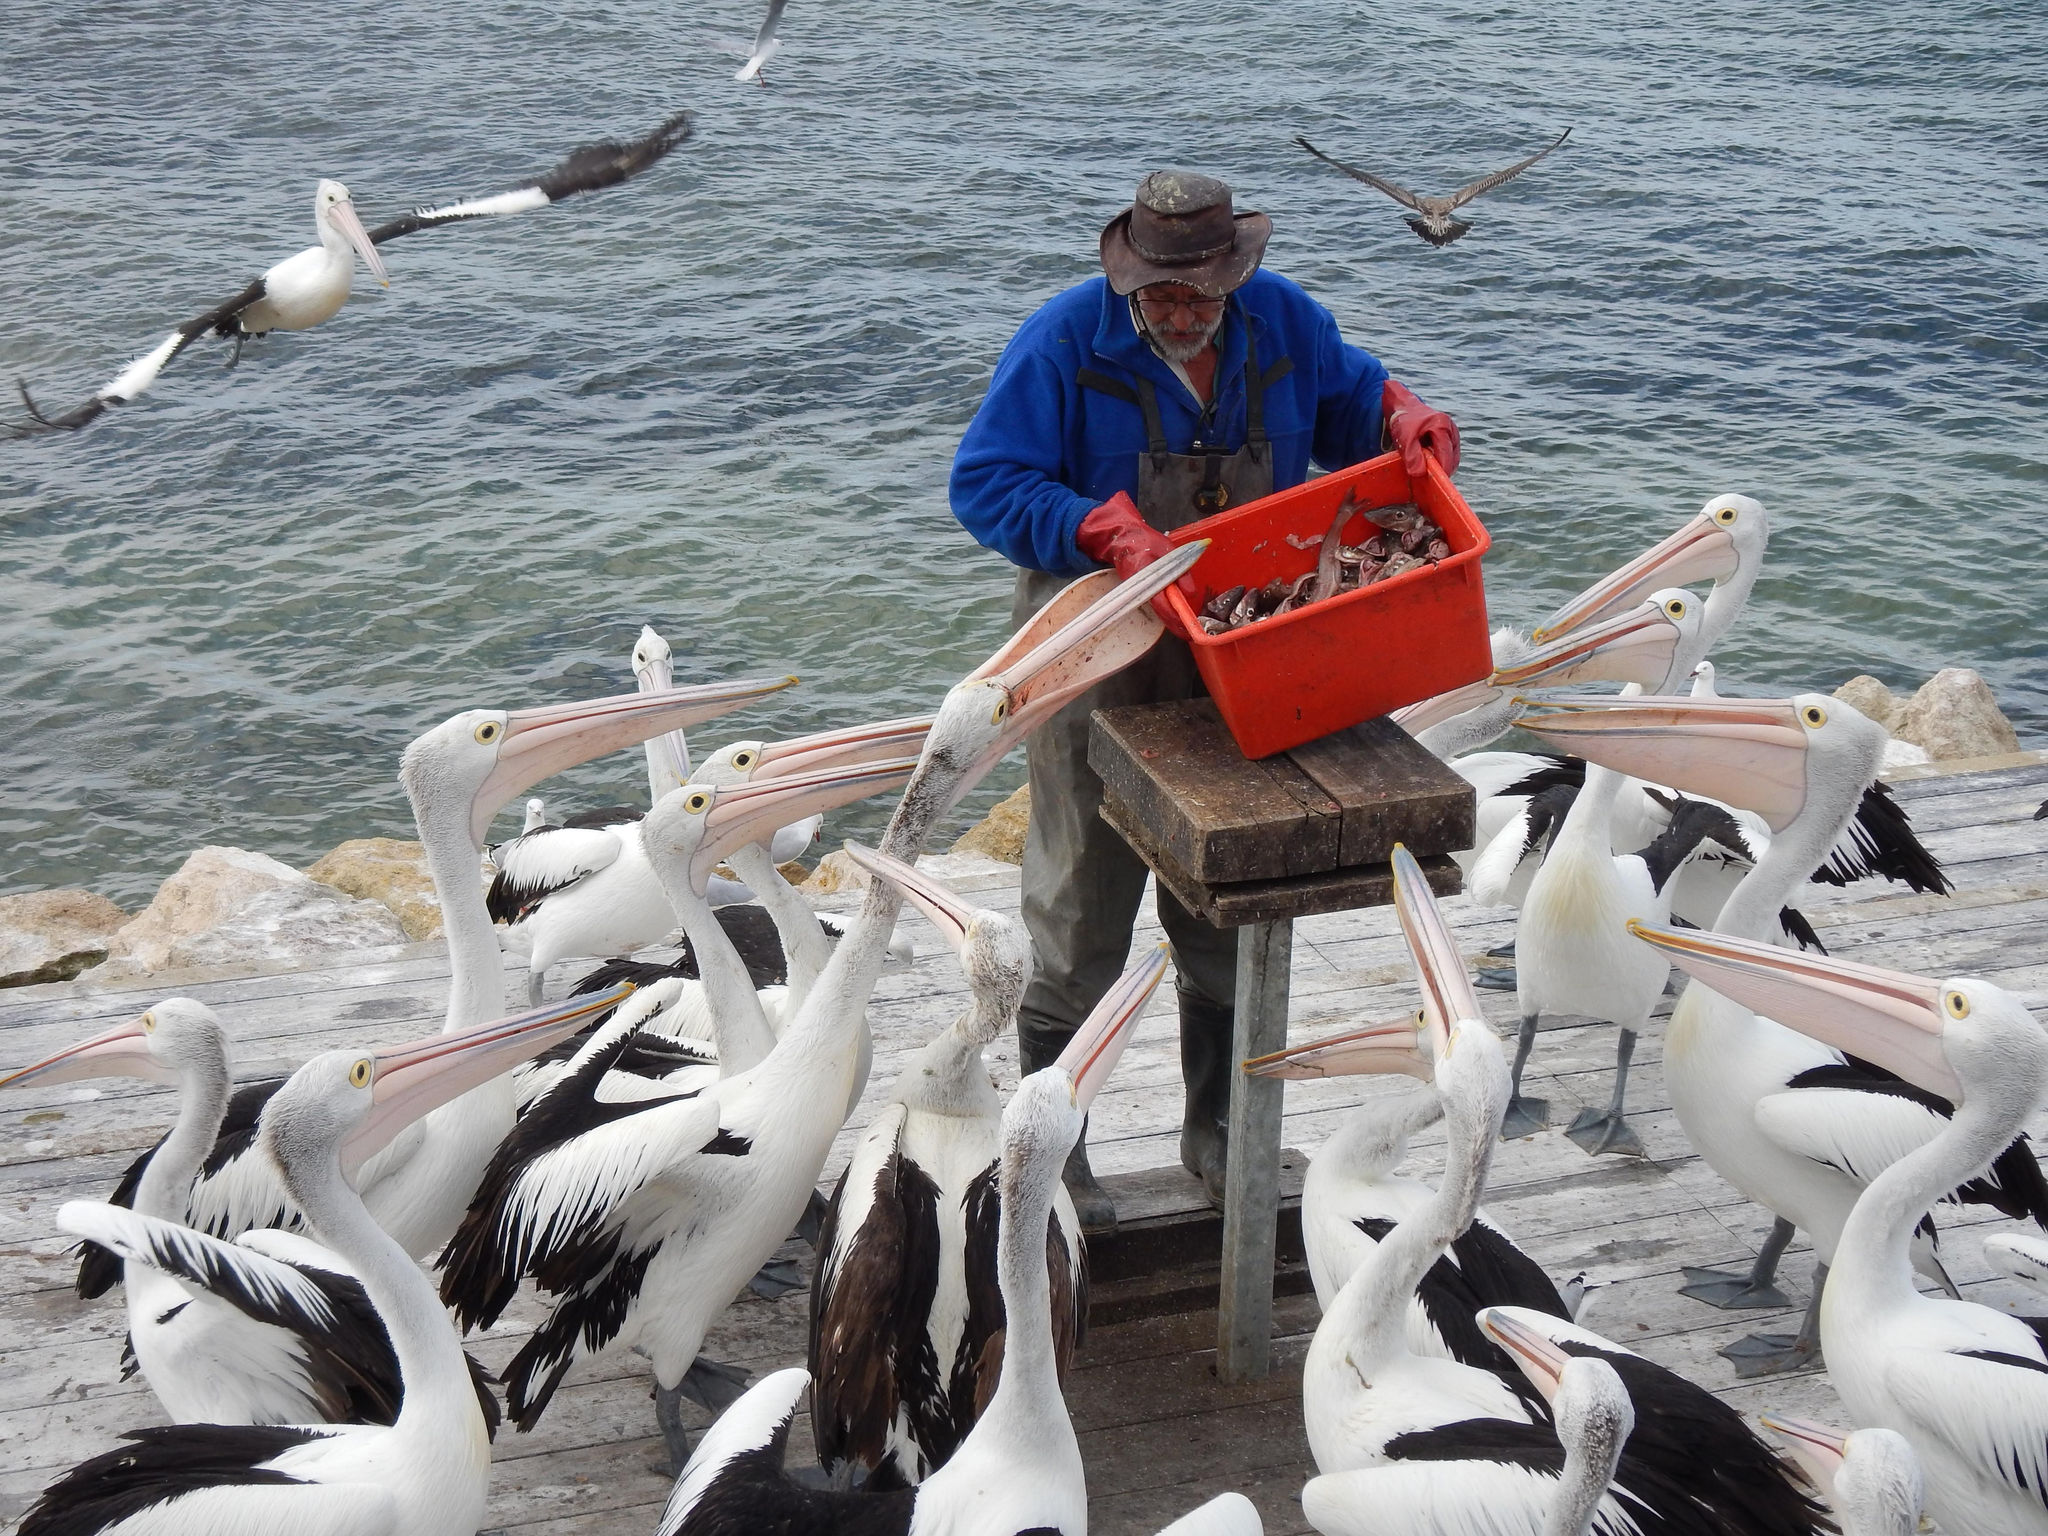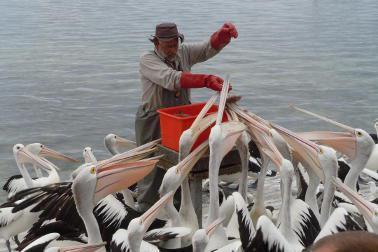The first image is the image on the left, the second image is the image on the right. For the images displayed, is the sentence "There is a red bucket surrounded by many pelicans." factually correct? Answer yes or no. Yes. 